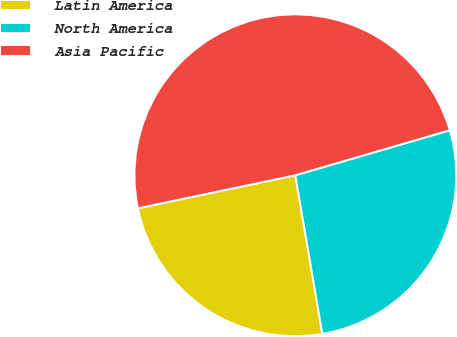Convert chart to OTSL. <chart><loc_0><loc_0><loc_500><loc_500><pie_chart><fcel>Latin America<fcel>North America<fcel>Asia Pacific<nl><fcel>24.39%<fcel>26.83%<fcel>48.78%<nl></chart> 